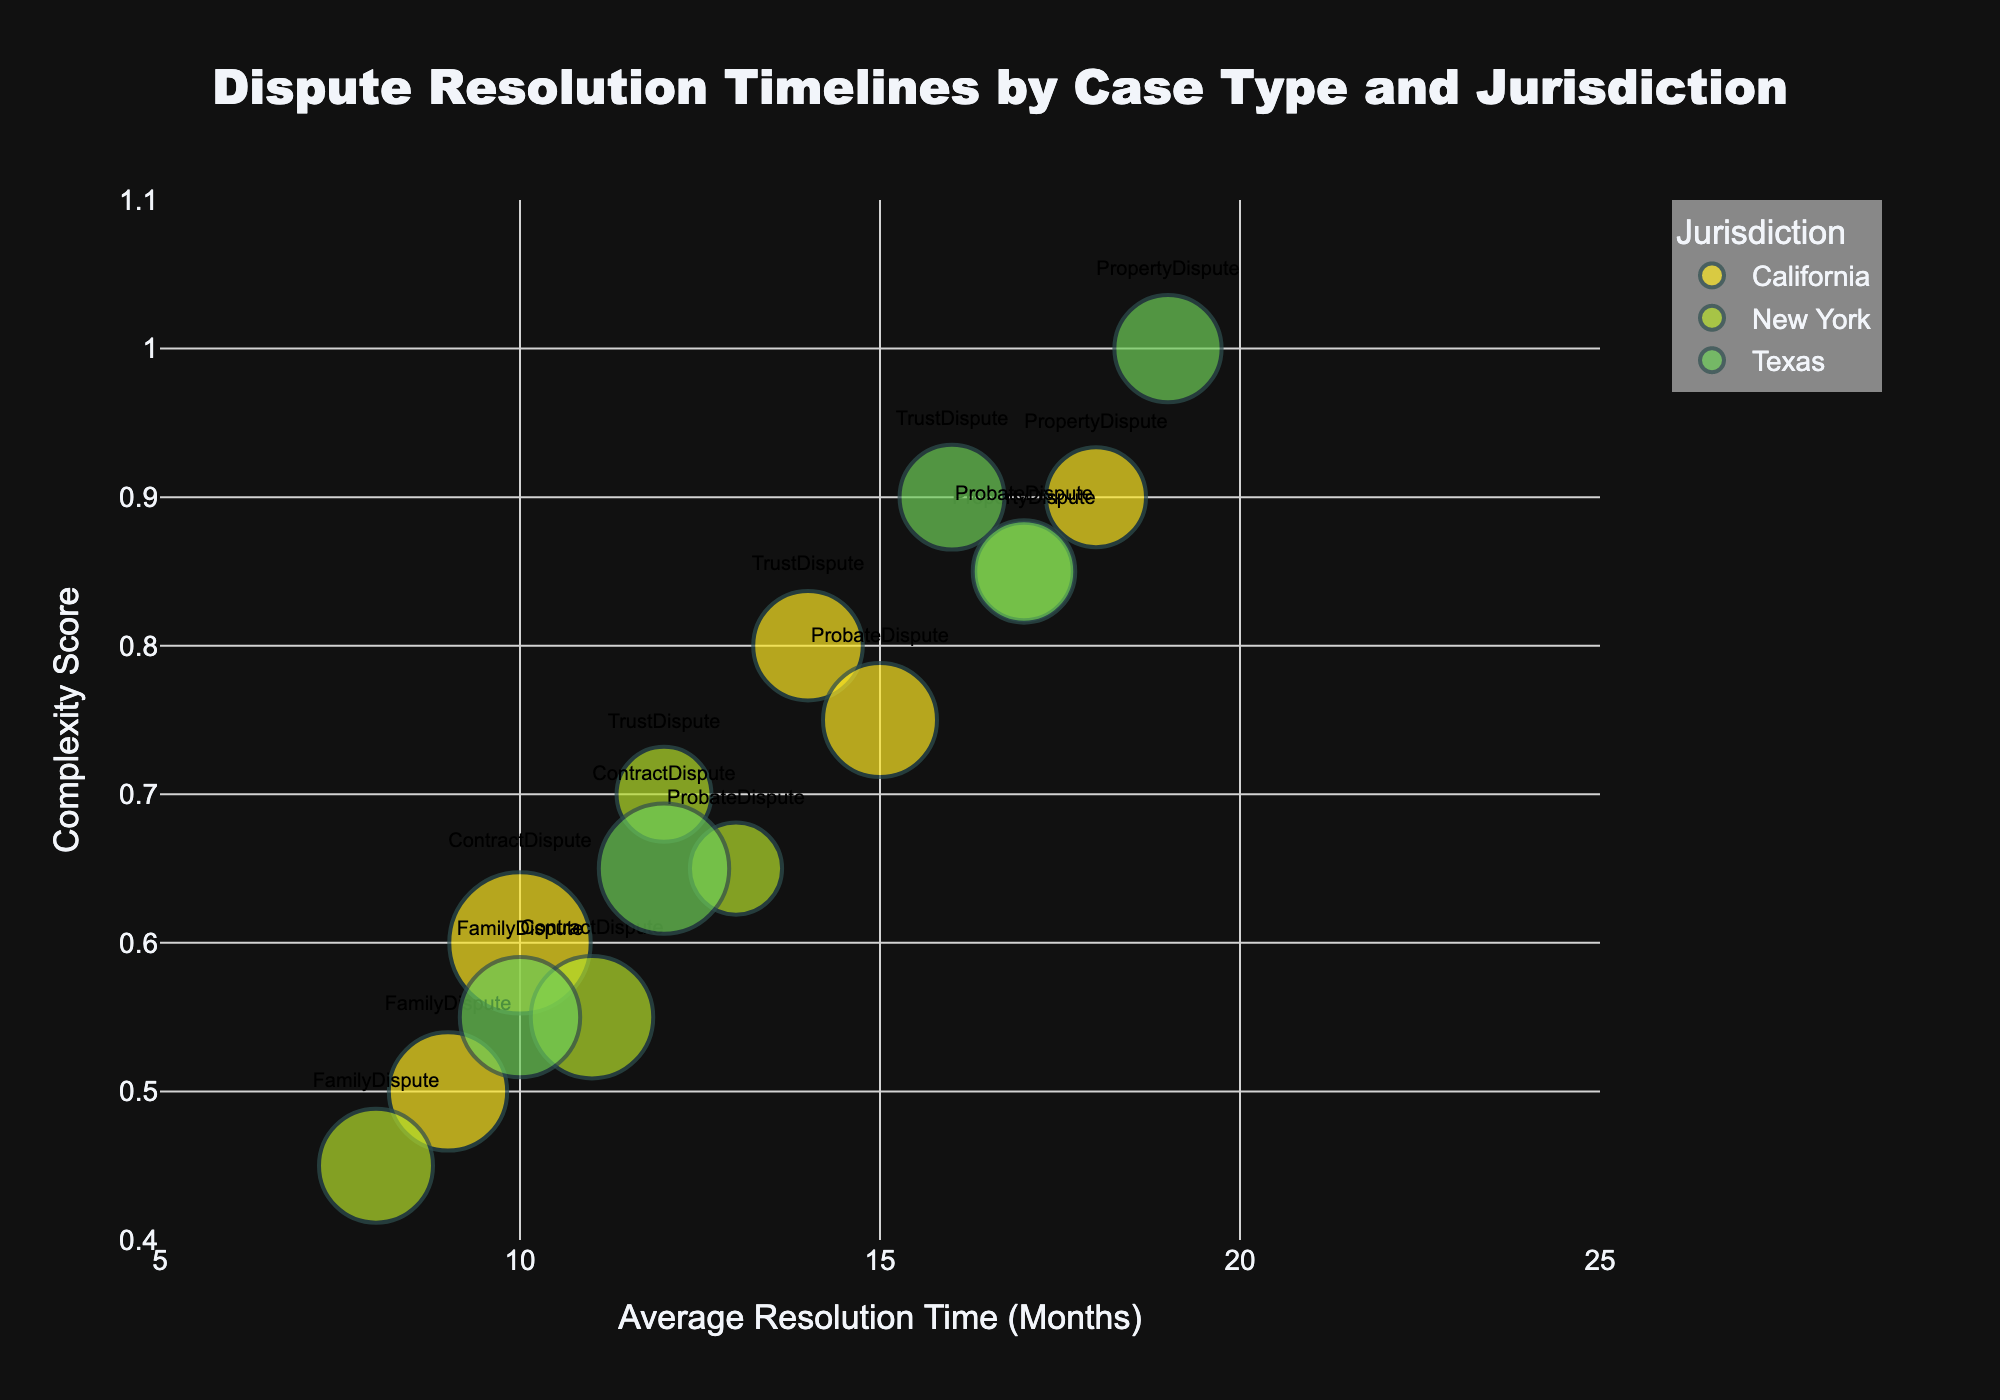How many types of cases are represented in the chart? Look at the list of case types that are displayed with different colors in the chart.
Answer: 5 Which jurisdiction has the most cases with a complexity score of 0.55? Identify the bubbles with a complexity score of 0.55, then compare the number of cases for each jurisdiction.
Answer: New York Which case type has the longest average resolution time in California? Find the bubbles corresponding to California with the highest average resolution time.
Answer: PropertyDispute What is the complexity score range covered by FamilyDisputes in all jurisdictions? Look for the bubbles labeled as FamilyDispute and note the smallest and largest Y-axis values (complexity scores).
Answer: 0.45 to 0.55 What are the average resolution times for contract disputes across all jurisdictions? Identify all bubbles tagged with ContractDispute and list their X-axis values (average resolution times).
Answer: 10, 11, 12 How does the average resolution time for ProbateDisputes in Texas compare to that in New York? Find the bubbles for ProbateDispute from Texas and New York and compare their position on the X-axis.
Answer: Texas takes 4 months longer than New York Which case type and jurisdiction combination has the highest complexity score? Find the bubble with the highest Y-axis value and note its case type and jurisdiction.
Answer: PropertyDispute, Texas Which jurisdiction resolves FamilyDisputes the quickest? Identify the FamilyDispute bubbles and compare their positions on the X-axis.
Answer: New York What is the relationship between the number of cases and bubble size in this chart? Observing the bubbles, larger bubbles correspond to a higher number of cases since size is determined by the number of cases.
Answer: Larger bubbles mean more cases Which case type in Texas has the longest average resolution time, and what is its complexity score? Look at the bubbles corresponding to Texas and find the one with the highest X-axis value. Note the complexity score from the Y-axis.
Answer: PropertyDispute, 1.0 